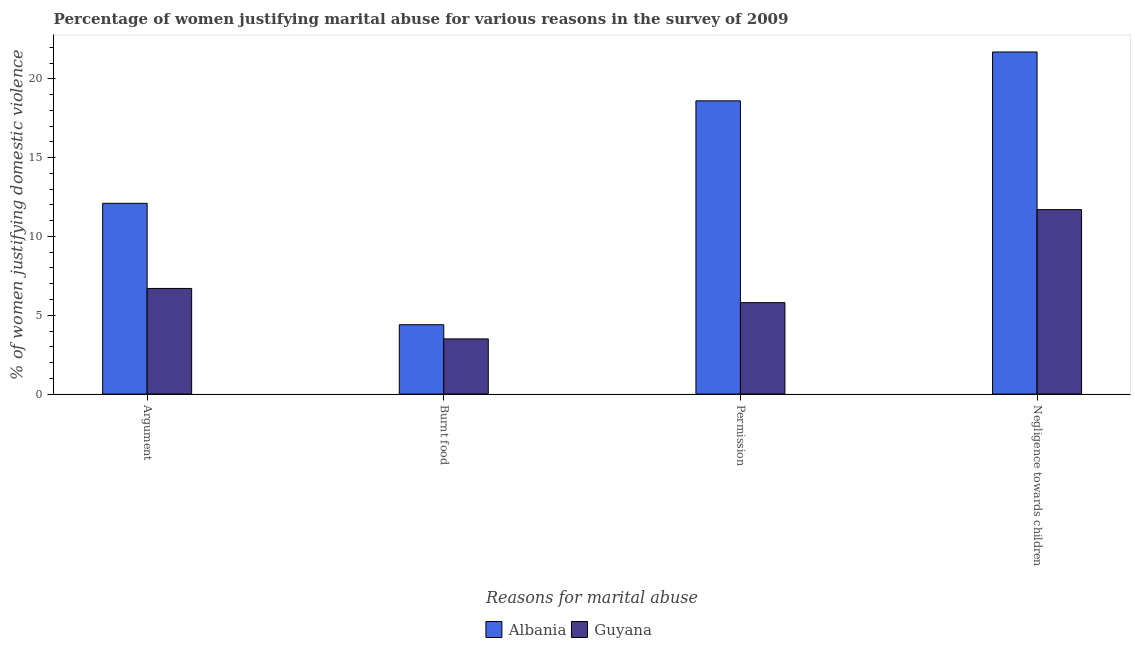How many different coloured bars are there?
Make the answer very short. 2. Are the number of bars per tick equal to the number of legend labels?
Your response must be concise. Yes. Are the number of bars on each tick of the X-axis equal?
Your answer should be very brief. Yes. How many bars are there on the 3rd tick from the left?
Keep it short and to the point. 2. What is the label of the 4th group of bars from the left?
Your answer should be very brief. Negligence towards children. What is the percentage of women justifying abuse in the case of an argument in Guyana?
Make the answer very short. 6.7. Across all countries, what is the maximum percentage of women justifying abuse in the case of an argument?
Provide a short and direct response. 12.1. Across all countries, what is the minimum percentage of women justifying abuse for burning food?
Ensure brevity in your answer.  3.5. In which country was the percentage of women justifying abuse for burning food maximum?
Give a very brief answer. Albania. In which country was the percentage of women justifying abuse for showing negligence towards children minimum?
Your response must be concise. Guyana. What is the difference between the percentage of women justifying abuse for showing negligence towards children in Guyana and the percentage of women justifying abuse for going without permission in Albania?
Provide a succinct answer. -6.9. What is the average percentage of women justifying abuse in the case of an argument per country?
Your answer should be very brief. 9.4. In how many countries, is the percentage of women justifying abuse in the case of an argument greater than 9 %?
Your response must be concise. 1. What is the ratio of the percentage of women justifying abuse for going without permission in Albania to that in Guyana?
Your response must be concise. 3.21. Is the percentage of women justifying abuse for burning food in Guyana less than that in Albania?
Your response must be concise. Yes. What is the difference between the highest and the second highest percentage of women justifying abuse for burning food?
Make the answer very short. 0.9. In how many countries, is the percentage of women justifying abuse in the case of an argument greater than the average percentage of women justifying abuse in the case of an argument taken over all countries?
Provide a succinct answer. 1. Is the sum of the percentage of women justifying abuse in the case of an argument in Albania and Guyana greater than the maximum percentage of women justifying abuse for going without permission across all countries?
Your answer should be very brief. Yes. Is it the case that in every country, the sum of the percentage of women justifying abuse in the case of an argument and percentage of women justifying abuse for going without permission is greater than the sum of percentage of women justifying abuse for showing negligence towards children and percentage of women justifying abuse for burning food?
Your answer should be very brief. No. What does the 1st bar from the left in Burnt food represents?
Your answer should be compact. Albania. What does the 2nd bar from the right in Permission represents?
Offer a very short reply. Albania. How many bars are there?
Provide a short and direct response. 8. Does the graph contain any zero values?
Provide a succinct answer. No. Does the graph contain grids?
Offer a very short reply. No. Where does the legend appear in the graph?
Your response must be concise. Bottom center. What is the title of the graph?
Provide a succinct answer. Percentage of women justifying marital abuse for various reasons in the survey of 2009. Does "St. Lucia" appear as one of the legend labels in the graph?
Make the answer very short. No. What is the label or title of the X-axis?
Make the answer very short. Reasons for marital abuse. What is the label or title of the Y-axis?
Provide a short and direct response. % of women justifying domestic violence. What is the % of women justifying domestic violence of Albania in Burnt food?
Give a very brief answer. 4.4. What is the % of women justifying domestic violence in Guyana in Burnt food?
Your response must be concise. 3.5. What is the % of women justifying domestic violence in Albania in Negligence towards children?
Provide a succinct answer. 21.7. What is the % of women justifying domestic violence of Guyana in Negligence towards children?
Offer a very short reply. 11.7. Across all Reasons for marital abuse, what is the maximum % of women justifying domestic violence of Albania?
Ensure brevity in your answer.  21.7. Across all Reasons for marital abuse, what is the maximum % of women justifying domestic violence in Guyana?
Your answer should be compact. 11.7. Across all Reasons for marital abuse, what is the minimum % of women justifying domestic violence in Albania?
Ensure brevity in your answer.  4.4. What is the total % of women justifying domestic violence of Albania in the graph?
Your response must be concise. 56.8. What is the total % of women justifying domestic violence of Guyana in the graph?
Ensure brevity in your answer.  27.7. What is the difference between the % of women justifying domestic violence in Albania in Argument and that in Burnt food?
Provide a succinct answer. 7.7. What is the difference between the % of women justifying domestic violence in Guyana in Argument and that in Burnt food?
Offer a very short reply. 3.2. What is the difference between the % of women justifying domestic violence of Guyana in Argument and that in Permission?
Provide a succinct answer. 0.9. What is the difference between the % of women justifying domestic violence of Guyana in Argument and that in Negligence towards children?
Your response must be concise. -5. What is the difference between the % of women justifying domestic violence of Albania in Burnt food and that in Permission?
Ensure brevity in your answer.  -14.2. What is the difference between the % of women justifying domestic violence in Albania in Burnt food and that in Negligence towards children?
Your answer should be compact. -17.3. What is the difference between the % of women justifying domestic violence in Guyana in Burnt food and that in Negligence towards children?
Your answer should be very brief. -8.2. What is the difference between the % of women justifying domestic violence in Albania in Burnt food and the % of women justifying domestic violence in Guyana in Negligence towards children?
Offer a terse response. -7.3. What is the difference between the % of women justifying domestic violence of Albania in Permission and the % of women justifying domestic violence of Guyana in Negligence towards children?
Offer a terse response. 6.9. What is the average % of women justifying domestic violence of Albania per Reasons for marital abuse?
Your response must be concise. 14.2. What is the average % of women justifying domestic violence of Guyana per Reasons for marital abuse?
Keep it short and to the point. 6.92. What is the difference between the % of women justifying domestic violence of Albania and % of women justifying domestic violence of Guyana in Argument?
Your answer should be very brief. 5.4. What is the difference between the % of women justifying domestic violence in Albania and % of women justifying domestic violence in Guyana in Negligence towards children?
Your answer should be compact. 10. What is the ratio of the % of women justifying domestic violence of Albania in Argument to that in Burnt food?
Your answer should be very brief. 2.75. What is the ratio of the % of women justifying domestic violence in Guyana in Argument to that in Burnt food?
Ensure brevity in your answer.  1.91. What is the ratio of the % of women justifying domestic violence in Albania in Argument to that in Permission?
Offer a very short reply. 0.65. What is the ratio of the % of women justifying domestic violence in Guyana in Argument to that in Permission?
Your response must be concise. 1.16. What is the ratio of the % of women justifying domestic violence in Albania in Argument to that in Negligence towards children?
Keep it short and to the point. 0.56. What is the ratio of the % of women justifying domestic violence of Guyana in Argument to that in Negligence towards children?
Provide a short and direct response. 0.57. What is the ratio of the % of women justifying domestic violence of Albania in Burnt food to that in Permission?
Offer a terse response. 0.24. What is the ratio of the % of women justifying domestic violence in Guyana in Burnt food to that in Permission?
Offer a very short reply. 0.6. What is the ratio of the % of women justifying domestic violence of Albania in Burnt food to that in Negligence towards children?
Your response must be concise. 0.2. What is the ratio of the % of women justifying domestic violence of Guyana in Burnt food to that in Negligence towards children?
Ensure brevity in your answer.  0.3. What is the ratio of the % of women justifying domestic violence in Albania in Permission to that in Negligence towards children?
Your response must be concise. 0.86. What is the ratio of the % of women justifying domestic violence in Guyana in Permission to that in Negligence towards children?
Offer a terse response. 0.5. What is the difference between the highest and the lowest % of women justifying domestic violence in Albania?
Provide a short and direct response. 17.3. 